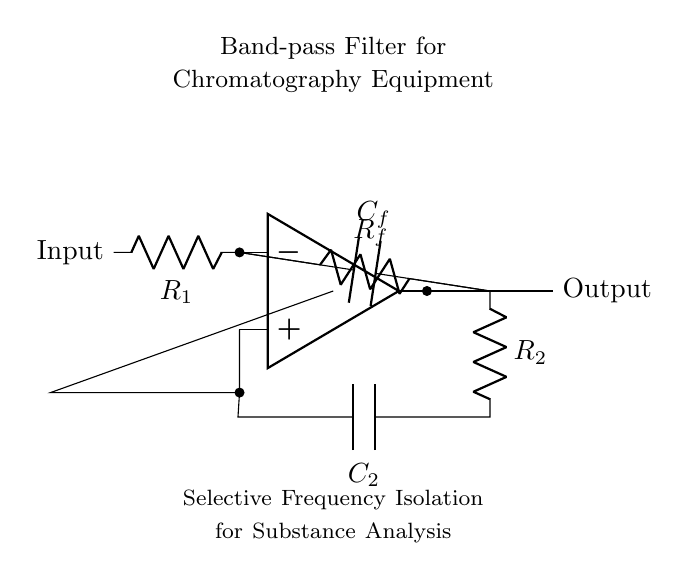What is the type of filter depicted in the circuit? The circuit is labeled as a "Band-pass Filter," which indicates its primary function is to pass frequencies within a specified range while attenuating frequencies outside that range.
Answer: Band-pass Filter Which components are used to implement the filter? The circuit diagram shows an operational amplifier, two resistors (R1, R2), and two capacitors (C2, Cf). These components are primarily responsible for creating the desired frequency response of the filter.
Answer: Operational amplifier, resistors, capacitors What is the function of the operational amplifier in this circuit? The operational amplifier serves as the main active component that amplifies the signal. It plays a crucial role in determining the gain and filtering characteristics of the circuit.
Answer: Amplification What frequency range does the filter isolate? Based on the circuit's design, a band-pass filter will isolate a specific frequency range, but the diagram does not specify exact values for frequencies, it indicates selectivity.
Answer: Selective frequency range What is the role of Capacitor C2 in the circuit? Capacitor C2 in the circuit works in conjunction with the resistors to form one part of the filtering network, particularly affecting the frequency response and cutoff frequency.
Answer: Frequency shaping How does the output relate to input in terms of signal processing? The output signal passes through the components and is influenced by the filter properties, allowing only certain frequency components to pass through, which are amplified by the operational amplifier.
Answer: Selectively amplified output What does R_f control in this filter circuit? The resistor R_f is part of the feedback mechanism which influences the gain of the operational amplifier, thus affecting the overall filtering response of the circuit.
Answer: Gain control 